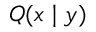Convert formula to latex. <formula><loc_0><loc_0><loc_500><loc_500>Q ( x | y )</formula> 